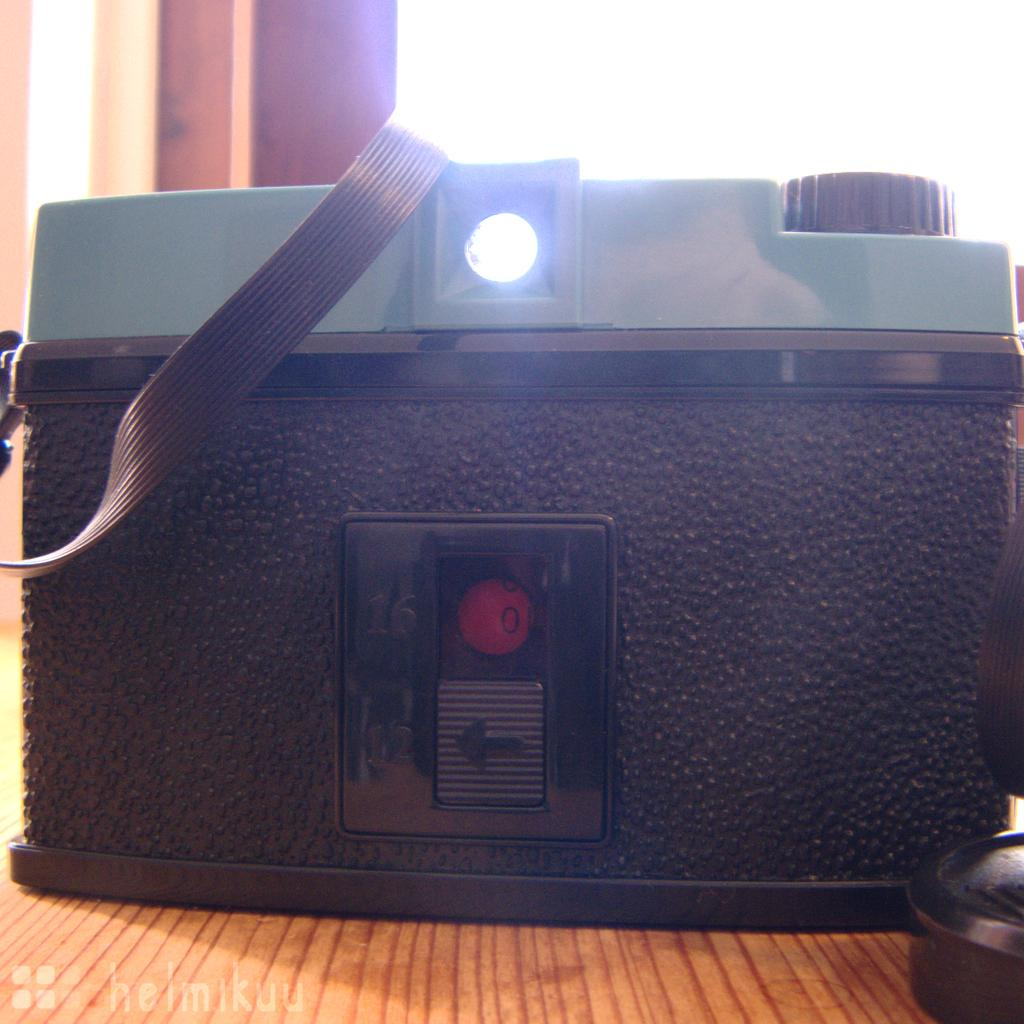What is the main subject of the image? The main subject of the image is a machine on a wooden object. What can be seen behind the wooden object? There is a wall behind the wooden object. Is there any indication of the image's origin or ownership? Yes, there is a watermark on the image. How many jellyfish are swimming near the machine in the image? There are no jellyfish present in the image; it features a machine on a wooden object with a wall in the background. Who is the manager of the machine in the image? The image does not provide any information about a manager or any personnel related to the machine. 